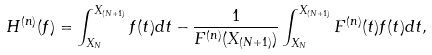Convert formula to latex. <formula><loc_0><loc_0><loc_500><loc_500>H ^ { ( n ) } ( f ) = \int _ { X _ { N } } ^ { X _ { ( N + 1 ) } } f ( t ) d t - \frac { 1 } { F ^ { ( n ) } ( X _ { ( N + 1 ) } ) } \int _ { X _ { N } } ^ { X _ { ( N + 1 ) } } F ^ { ( n ) } ( t ) f ( t ) d t ,</formula> 